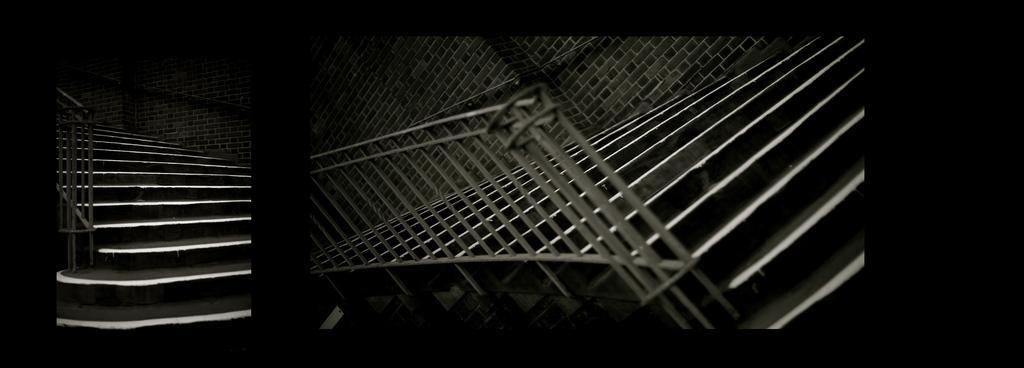Could you give a brief overview of what you see in this image? This is a collage image. Here I can see two images. In the images there are stairs, handrails and walls. The background is in black color. 